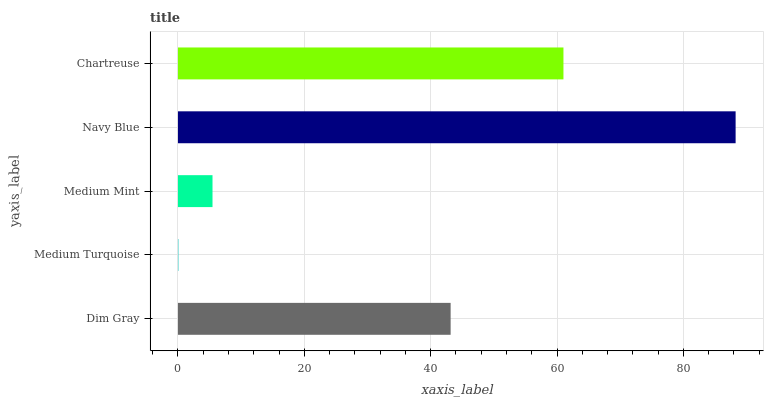Is Medium Turquoise the minimum?
Answer yes or no. Yes. Is Navy Blue the maximum?
Answer yes or no. Yes. Is Medium Mint the minimum?
Answer yes or no. No. Is Medium Mint the maximum?
Answer yes or no. No. Is Medium Mint greater than Medium Turquoise?
Answer yes or no. Yes. Is Medium Turquoise less than Medium Mint?
Answer yes or no. Yes. Is Medium Turquoise greater than Medium Mint?
Answer yes or no. No. Is Medium Mint less than Medium Turquoise?
Answer yes or no. No. Is Dim Gray the high median?
Answer yes or no. Yes. Is Dim Gray the low median?
Answer yes or no. Yes. Is Navy Blue the high median?
Answer yes or no. No. Is Navy Blue the low median?
Answer yes or no. No. 